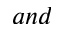<formula> <loc_0><loc_0><loc_500><loc_500>a n d</formula> 